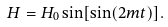Convert formula to latex. <formula><loc_0><loc_0><loc_500><loc_500>H = H _ { 0 } \sin [ \sin ( 2 m t ) ] .</formula> 